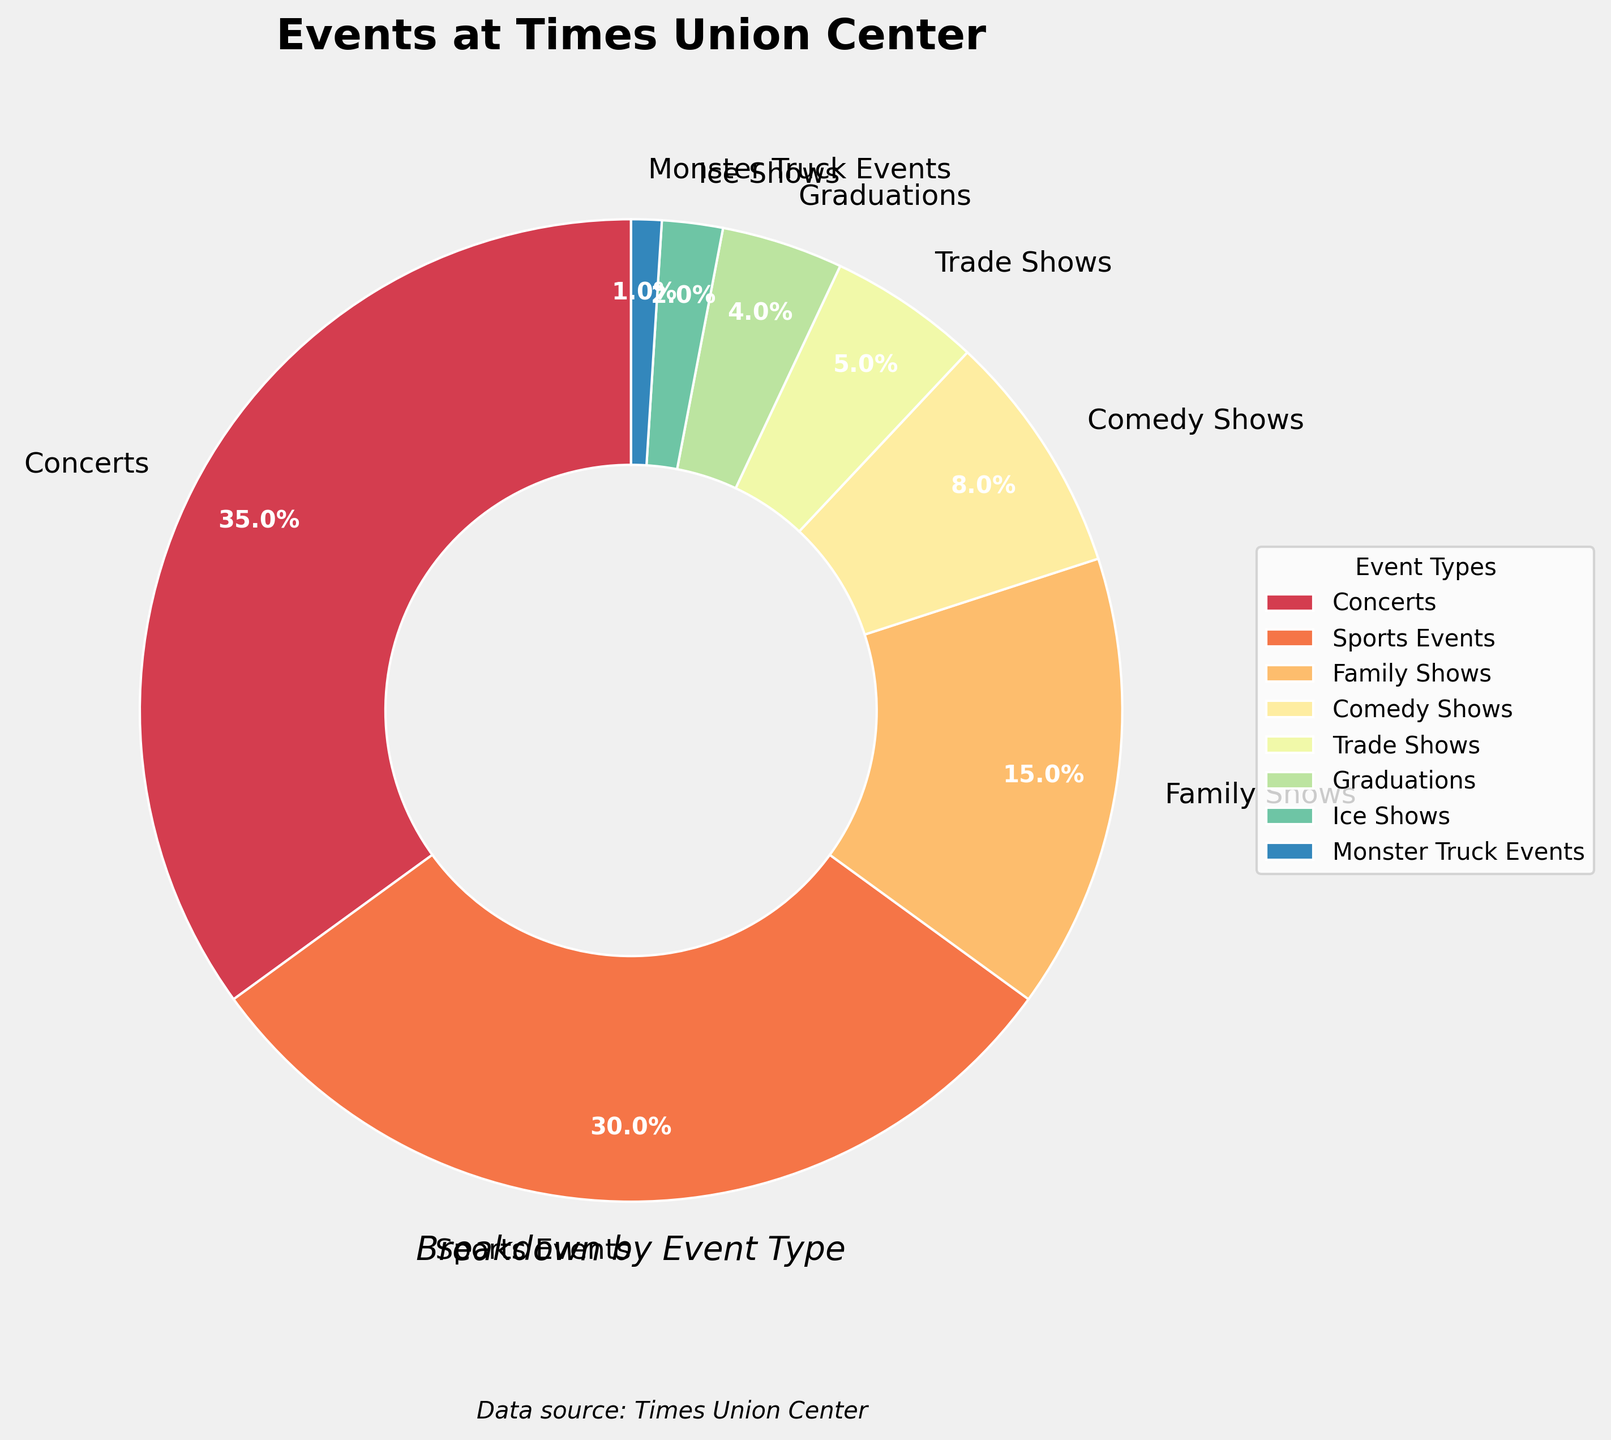What percentage of events are either concerts or sports events? To determine the combined percentage of concerts and sports events, add their respective percentages: 35% for concerts and 30% for sports events. Thus, 35% + 30% = 65%.
Answer: 65% Which event type has a higher percentage, family shows or comedy shows? Compare the percentages for family shows (15%) and comedy shows (8%). Since 15% is greater than 8%, family shows have a higher percentage.
Answer: Family shows What is the least common event type hosted at the Times Union Center? By reviewing the chart, find the event type with the smallest percentage. Monster truck events have the lowest percentage at 1%.
Answer: Monster truck events Are graduations and ice shows equally common, and if not, what is the difference in their percentages? Compare the percentages: graduations (4%) and ice shows (2%). They are not equal. The difference is 4% - 2% = 2%.
Answer: No, the difference is 2% How many event types have a percentage of 10% or more? Identify the event types with percentages equal to or greater than 10%. They are concerts (35%), sports events (30%), and family shows (15%). Thus, there are 3 event types.
Answer: 3 Which event type uses a purple shade in the pie chart? Visual inspection of the pie chart indicates that family shows are associated with a purple shade.
Answer: Family shows By what factor is trade shows more common than monster truck events? Compare the percentages: trade shows (5%) and monster truck events (1%). The factor is 5% / 1% = 5. Thus, trade shows are 5 times more common than monster truck events.
Answer: 5 How does the percentage of comedy shows compare to the sum of ice shows and monster truck events? Calculate the sum of ice shows (2%) and monster truck events (1%): 2% + 1% = 3%. Compare it with comedy shows (8%). Since 8% > 3%, comedy shows have a higher percentage.
Answer: Comedy shows have a higher percentage What is the average percentage of the five least common event types? Identify the five least common event types: ice shows (2%), graduations (4%), trade shows (5%), comedy shows (8%), and family shows (15%). Calculate their average: (2% + 4% + 5% + 8% + 15%) / 5 = 6.8%.
Answer: 6.8% If the percentage of concerts increased by 5%, what would their new percentage be? Add 5% to the current percentage of concerts (35%): 35% + 5% = 40%.
Answer: 40% 